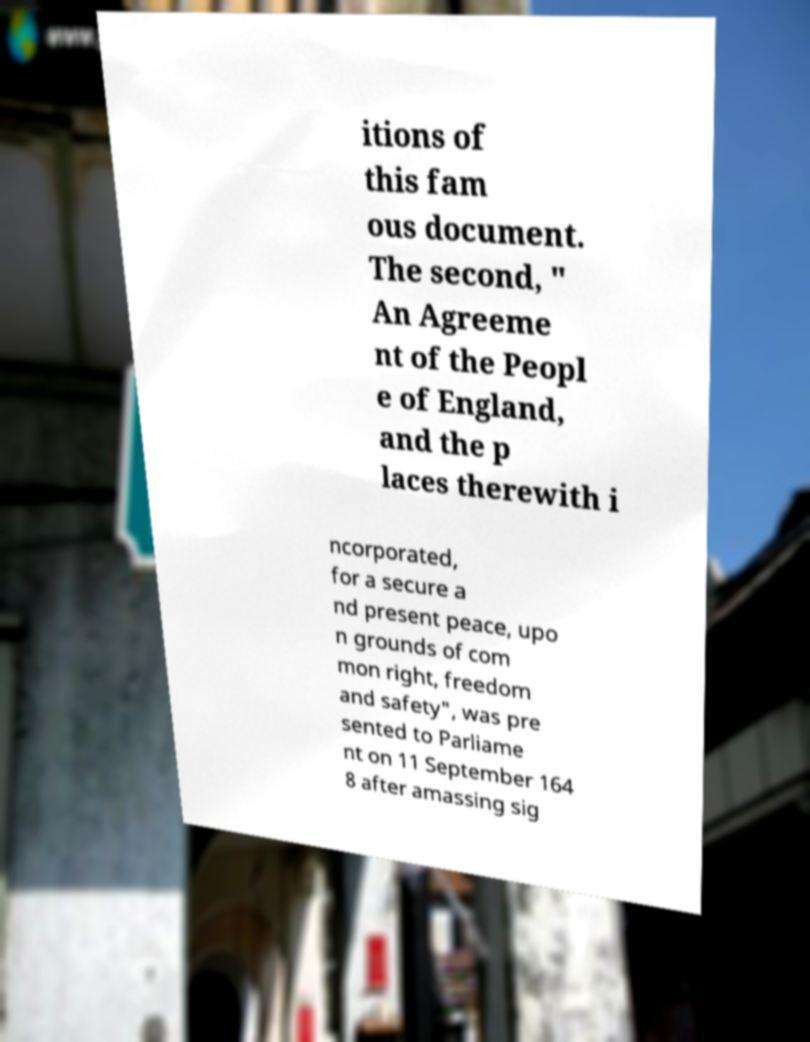Could you extract and type out the text from this image? itions of this fam ous document. The second, " An Agreeme nt of the Peopl e of England, and the p laces therewith i ncorporated, for a secure a nd present peace, upo n grounds of com mon right, freedom and safety", was pre sented to Parliame nt on 11 September 164 8 after amassing sig 